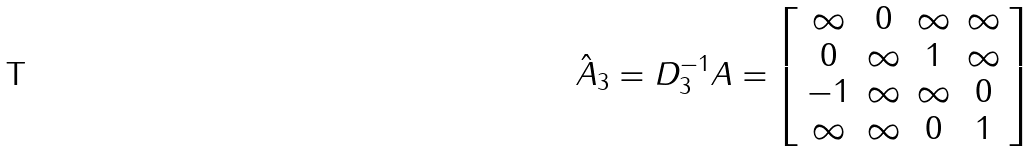<formula> <loc_0><loc_0><loc_500><loc_500>\hat { A } _ { 3 } = D _ { 3 } ^ { - 1 } A = \left [ \begin{array} { c c c c c } \infty & 0 & \infty & \infty \\ 0 & \infty & 1 & \infty \\ - 1 & \infty & \infty & 0 \\ \infty & \infty & 0 & 1 \end{array} \right ]</formula> 